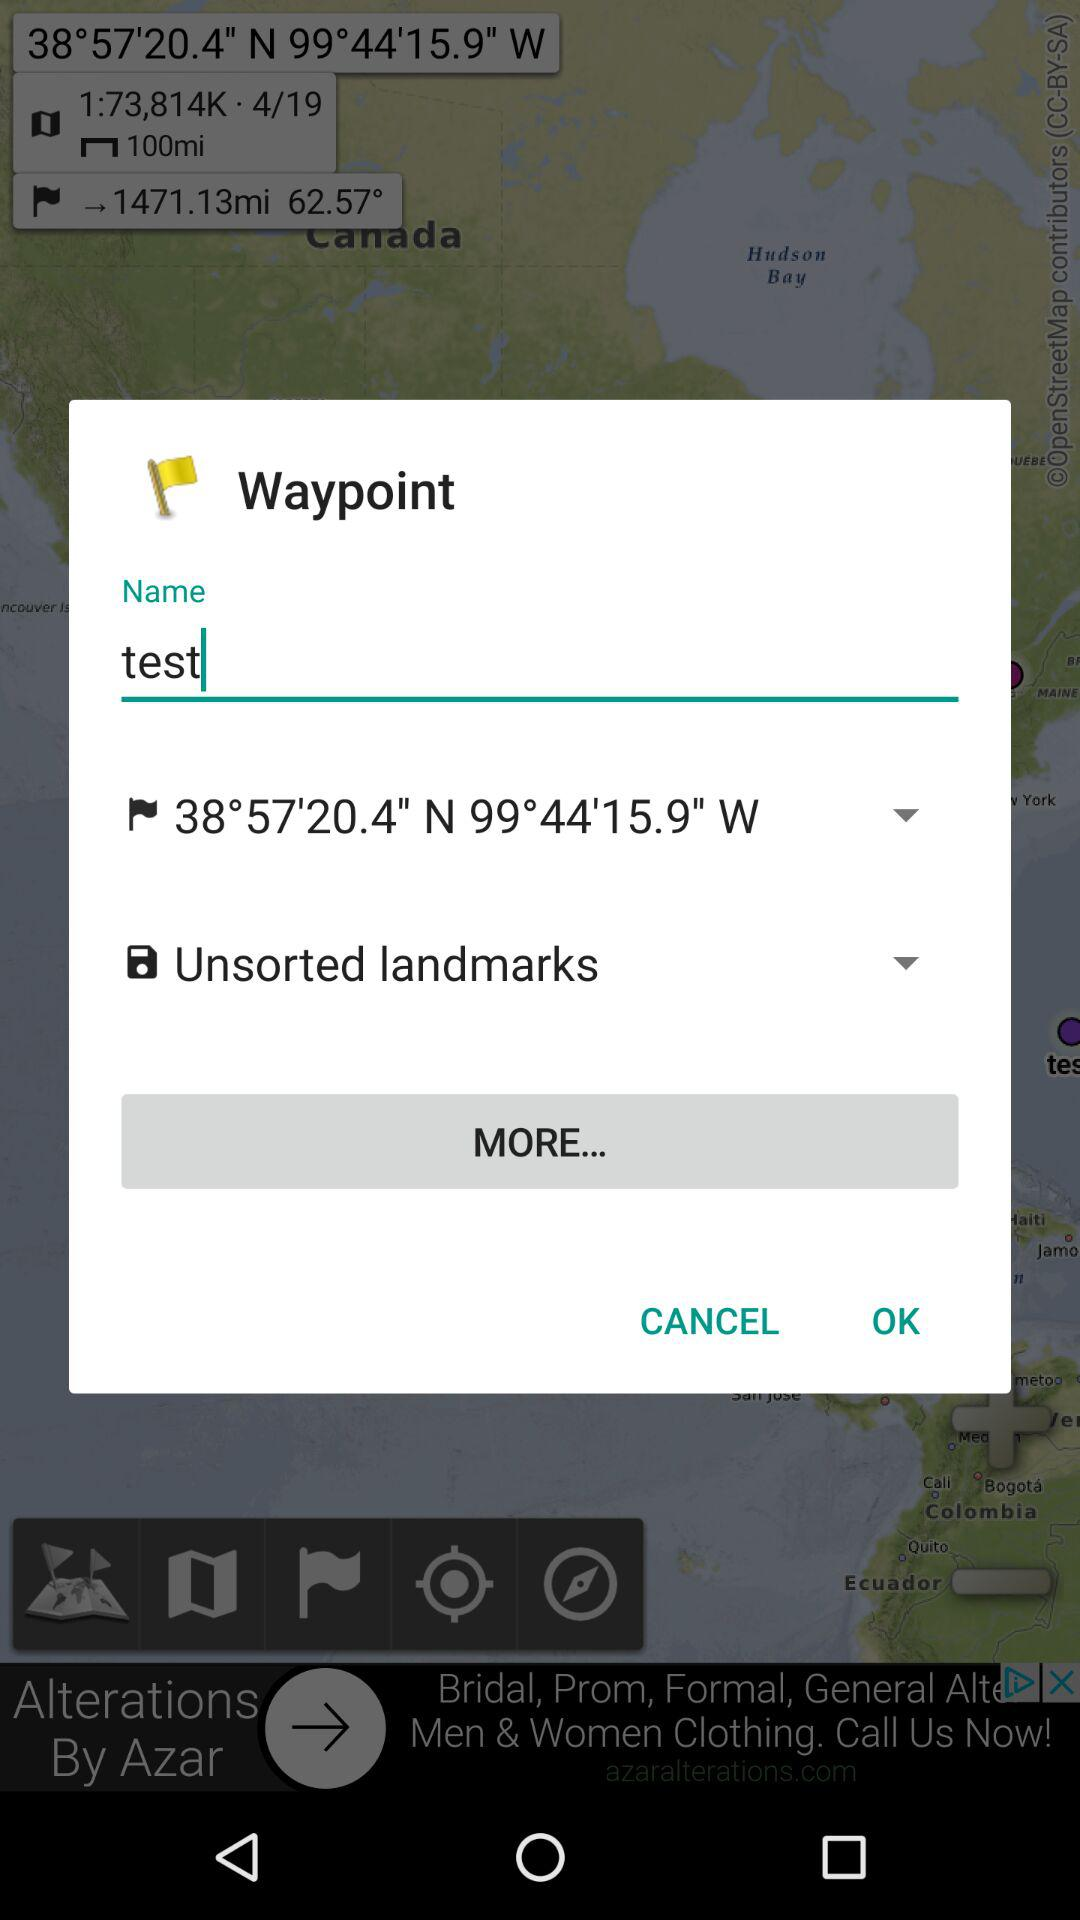What's the name? The name is "test". 